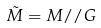<formula> <loc_0><loc_0><loc_500><loc_500>\tilde { M } = M / / G</formula> 